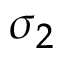Convert formula to latex. <formula><loc_0><loc_0><loc_500><loc_500>\sigma _ { 2 }</formula> 